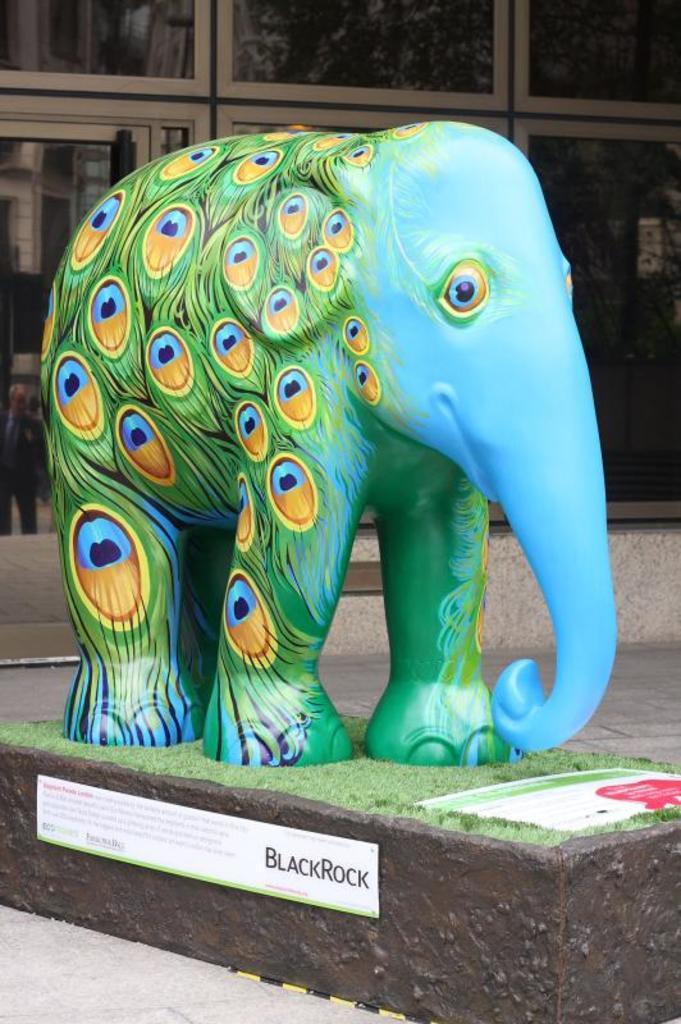Can you describe this image briefly? In the foreground of this image, there is a sculpture of an elephant. On the bottom, there is a board. In the background, there is a glass wall. 